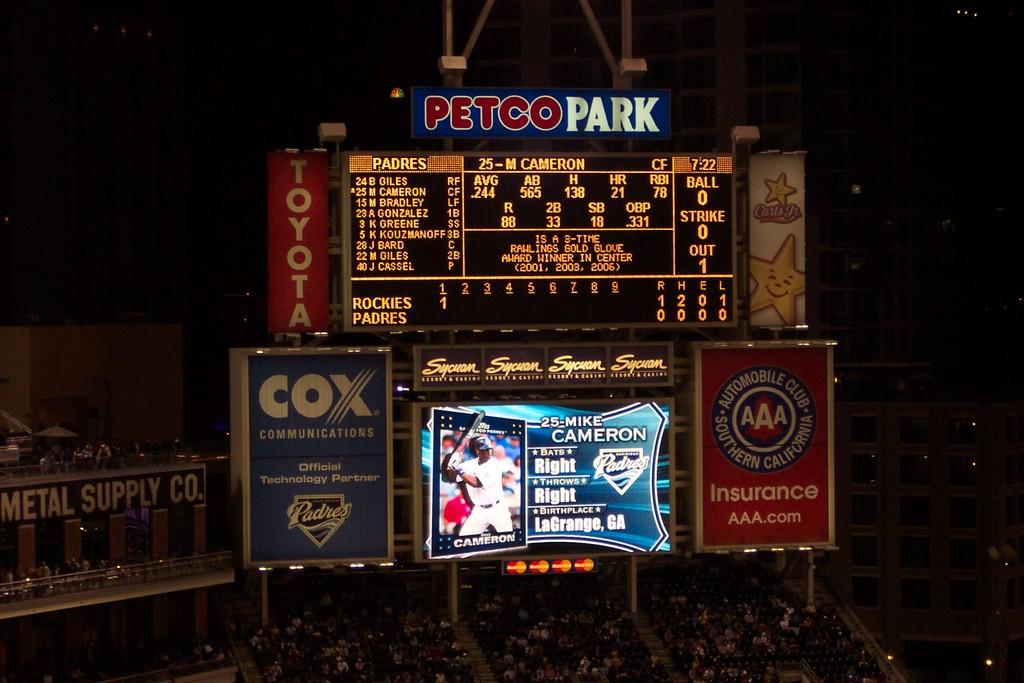Provide a one-sentence caption for the provided image. A large digital scoreboard at a baseball stadium with the name Petco Park. 